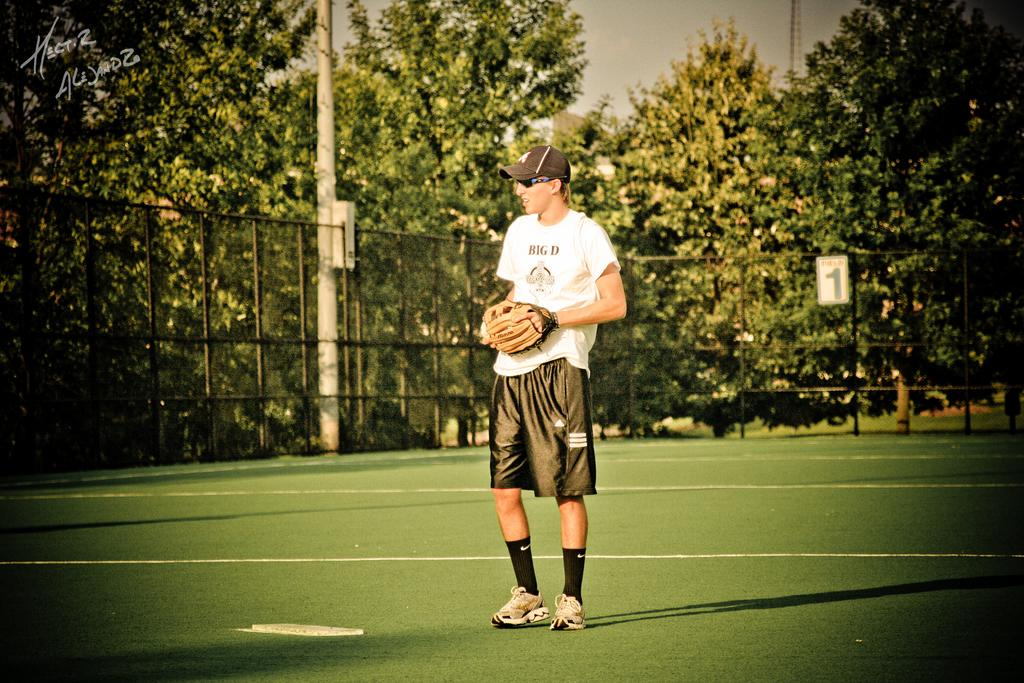What is the main subject of the image? There is a man in the image. What is the man doing in the image? The man is standing on the ground. Can you describe the man's clothing in the image? The man is wearing a cap, sunglasses, and a white t-shirt. What can be seen in the background of the image? There are trees and a pole in the background of the image. What is the boundary around the ground in the image? There is a boundary around the ground in the image. How many legs does the note have in the image? There is no note present in the image, so it is not possible to determine how many legs it might have. 